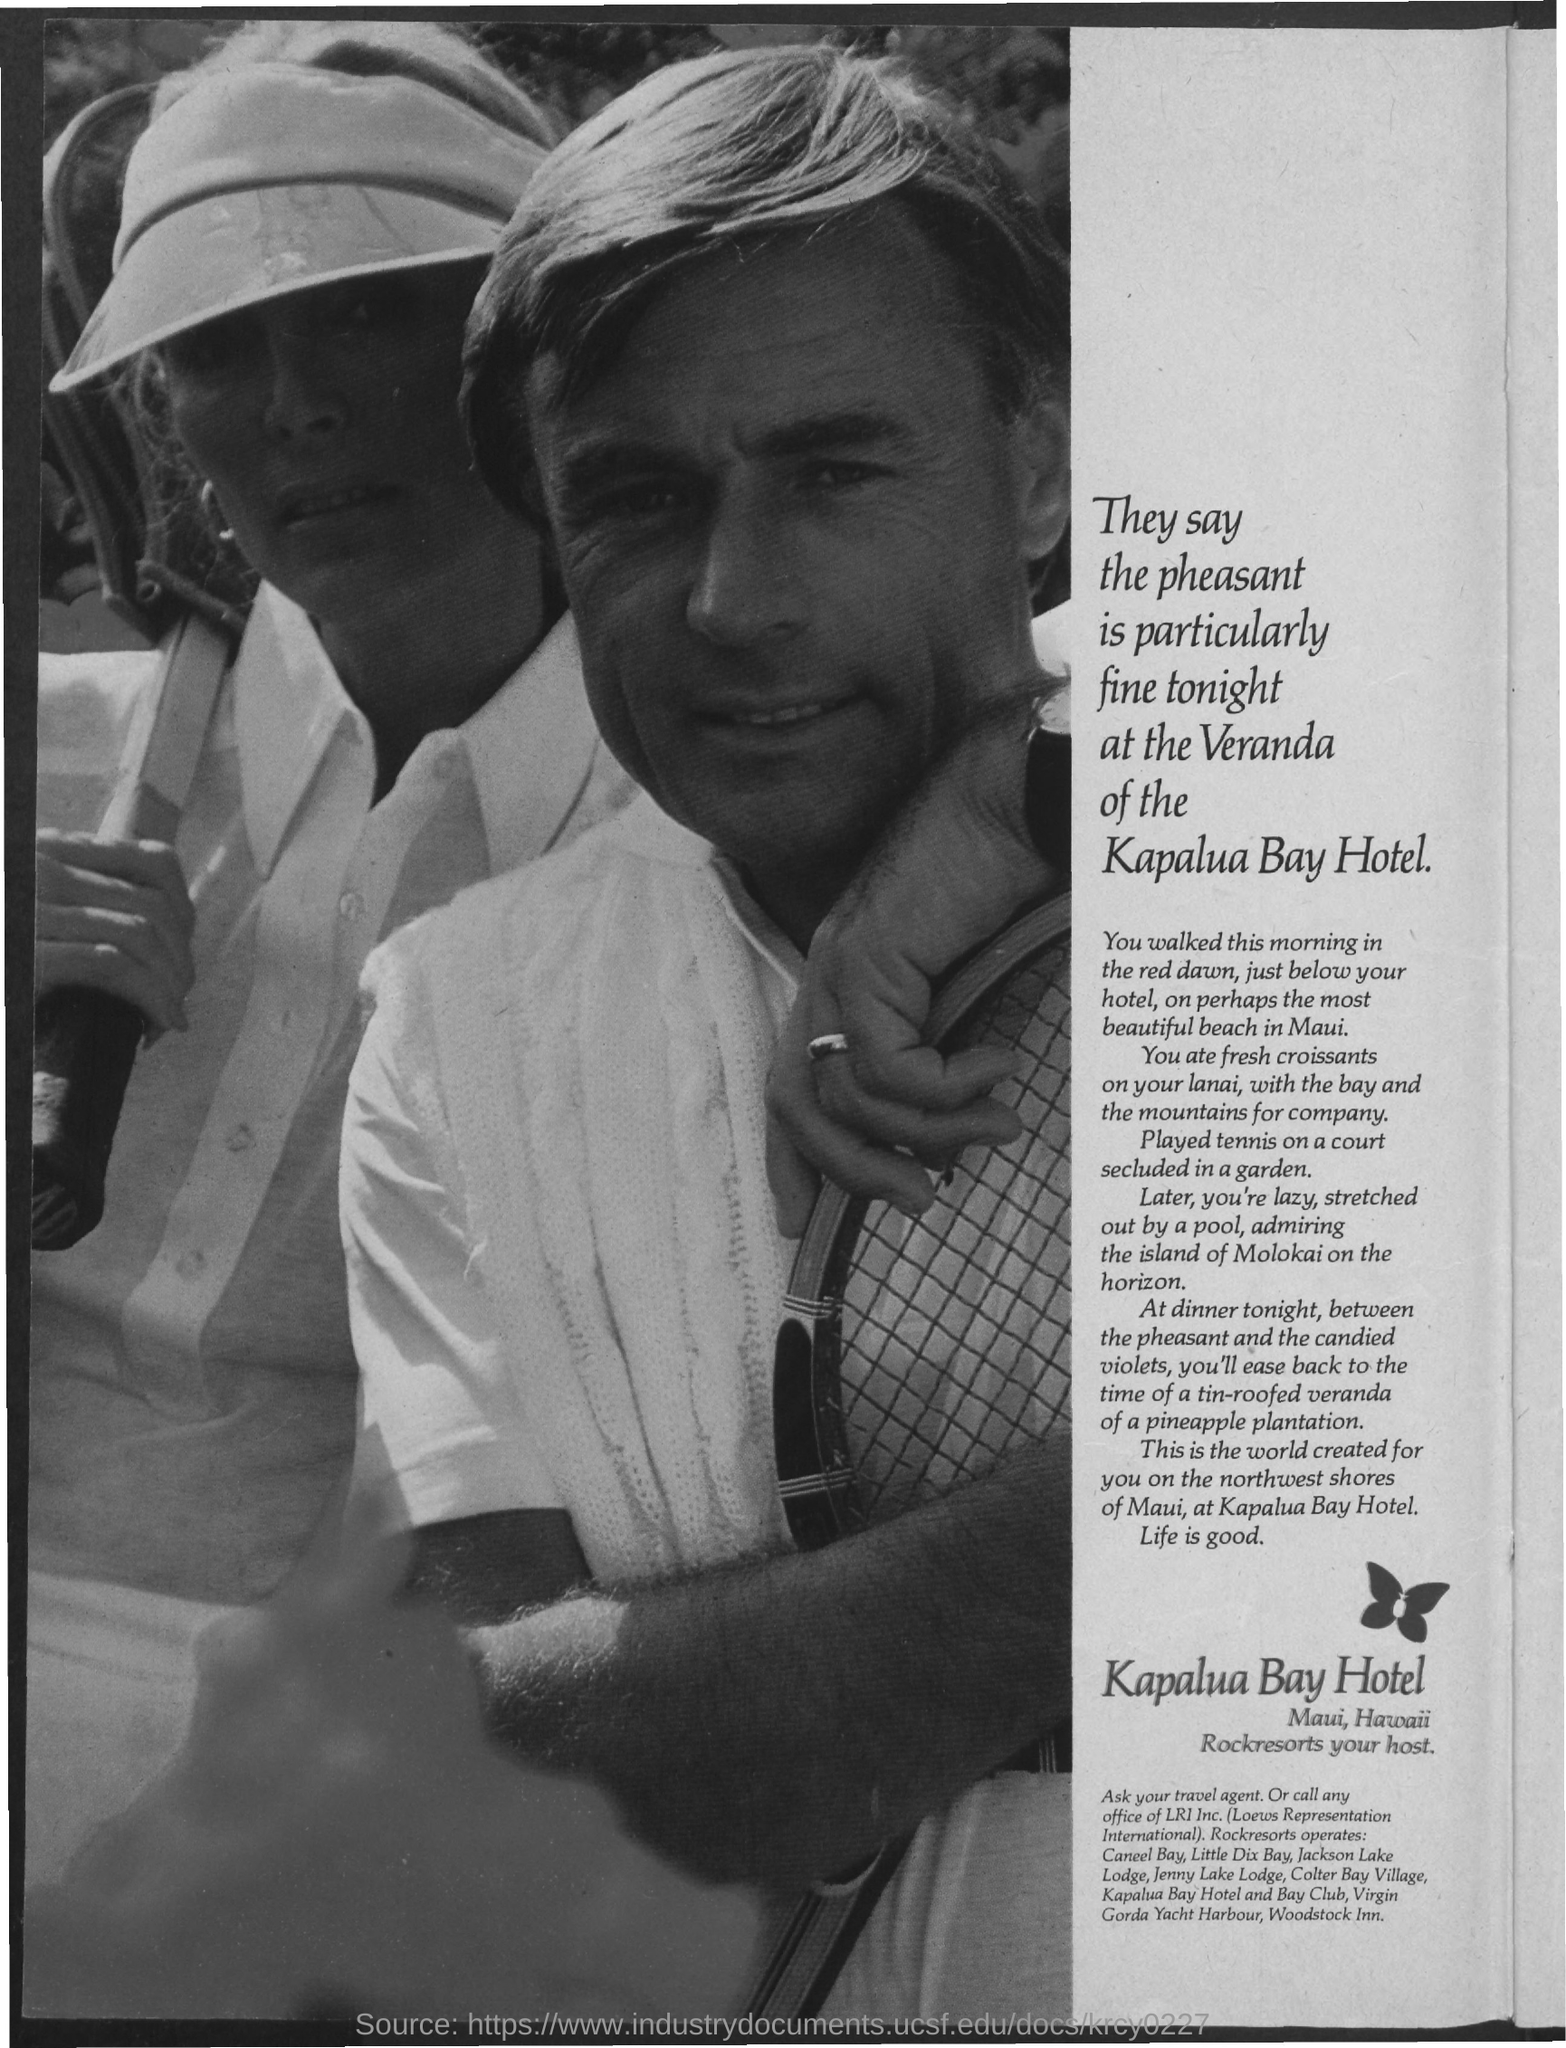Where is kapulua bay hotel located at?
Make the answer very short. Maui, Hawaii. 